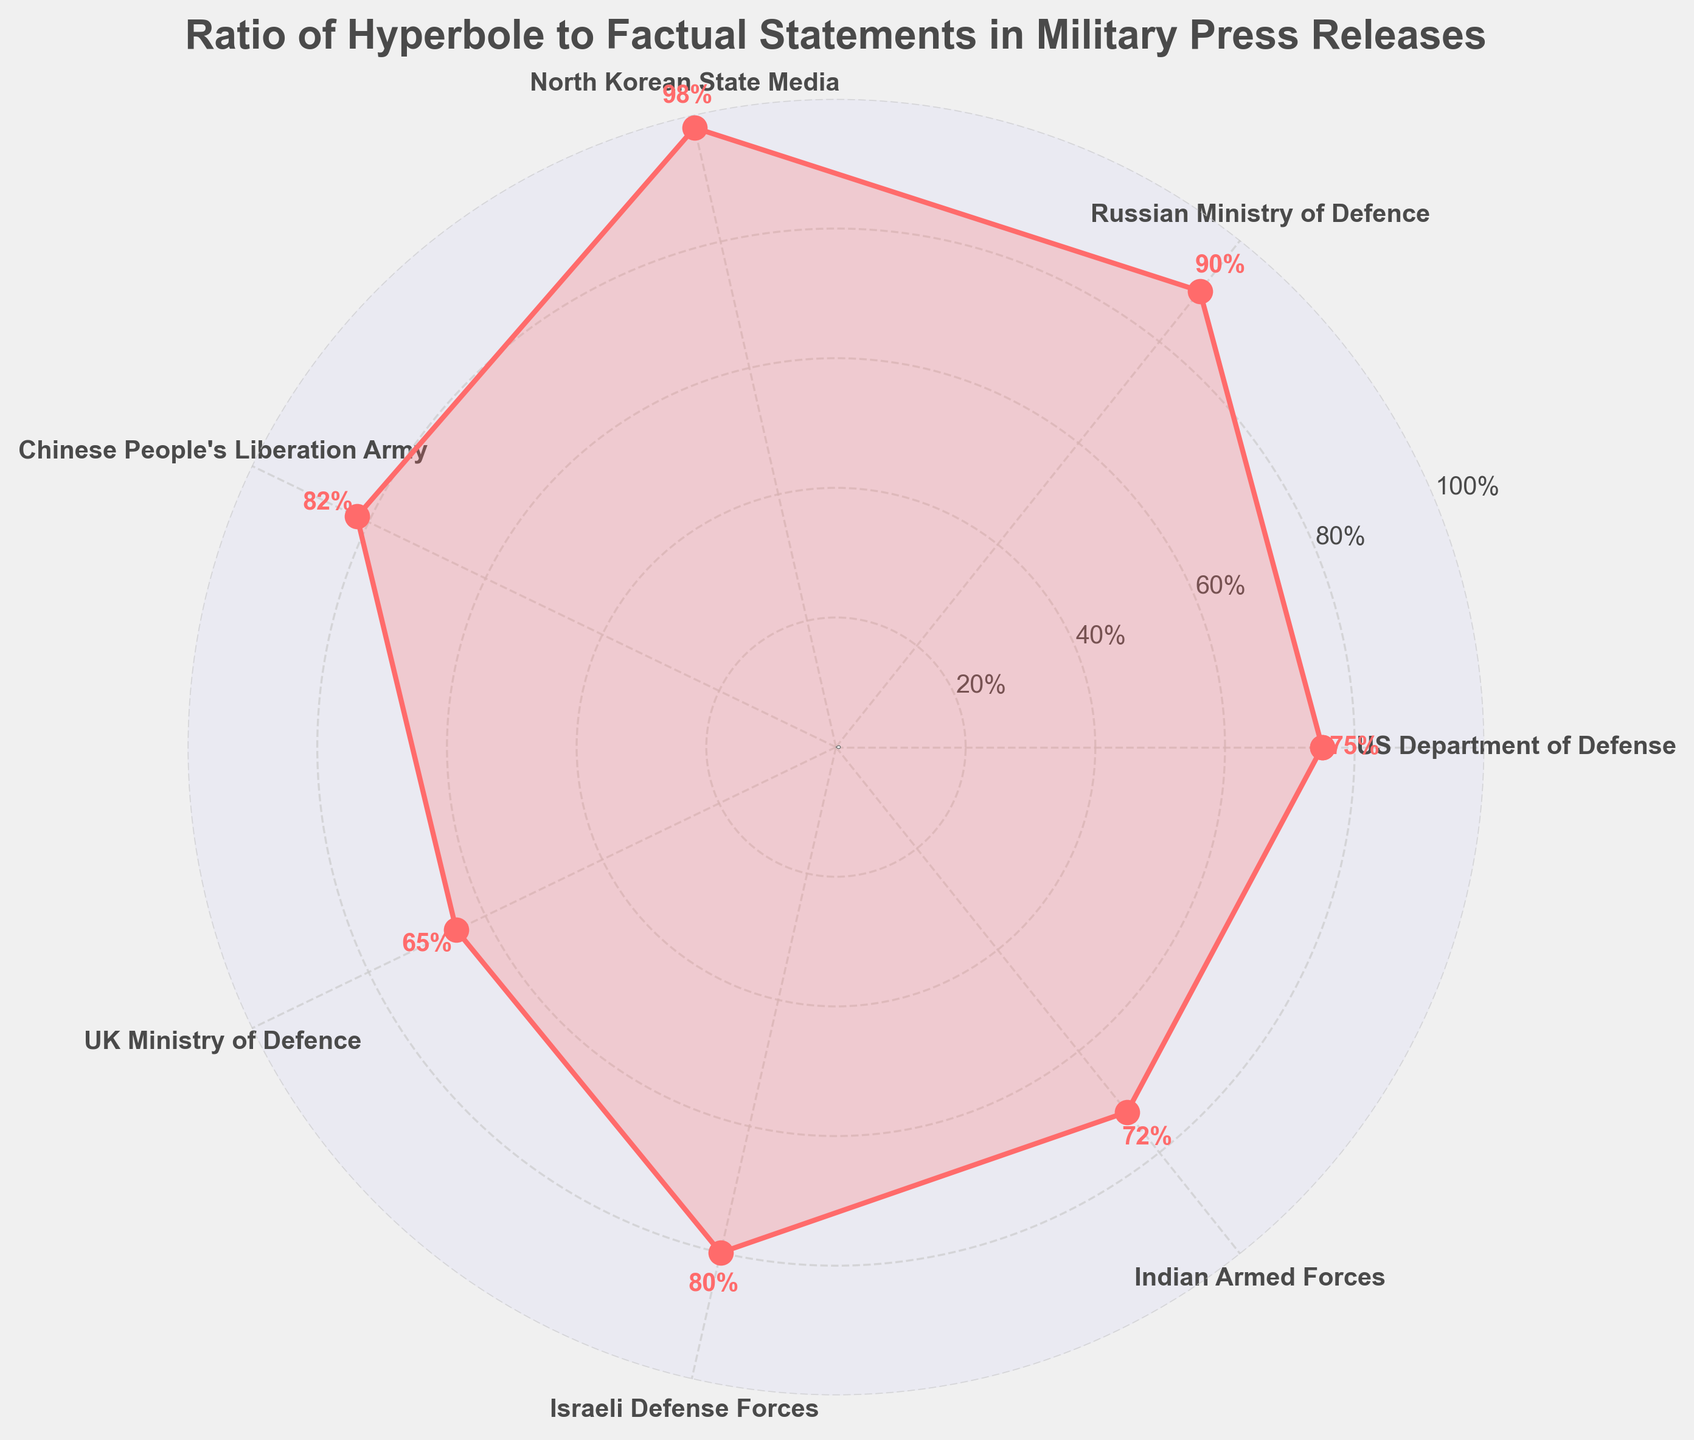How many military organizations are represented in the figure? Count the number of labeled categories in the plot. There are 7 categories represented.
Answer: 7 Which military organization has the highest ratio of hyperbole to factual statements? Identify the category with the highest value indicated on the plot. The North Korean State Media has the highest ratio at 98%.
Answer: North Korean State Media What is the range of the values represented in the figure? Subtract the smallest value from the highest value shown in the plot. The range is 98 (North Korean State Media) - 65 (UK Ministry of Defence) = 33.
Answer: 33 Which organization has the smallest ratio of hyperbole to factual statements? Identify the category with the lowest value indicated on the plot. The UK Ministry of Defence has the smallest ratio at 65%.
Answer: UK Ministry of Defence What is the median value of the ratios? Arrange the values in ascending order and find the middle value. Ordered values: 65, 72, 75, 80, 82, 90, 98. The median value, which is the fourth value in this ordered list, is 80.
Answer: 80 What is the average (mean) ratio of hyperbole to factual statements in the figure? Sum all the values and divide by the number of categories. (75 + 90 + 98 + 82 + 65 + 80 + 72) / 7 = 562 / 7 ≈ 80.29
Answer: 80.29 Which two organizations have the most similar ratios? Calculate the differences between each pair of values and find the smallest difference. The smallest difference is between the Israeli Defense Forces (80) and the Indian Armed Forces (72), a difference of 8.
Answer: Israeli Defense Forces & Indian Armed Forces How many organizations have a ratio equal to or above 80%? Count the categories that have values 80% or higher. The US Department of Defense (75), Russian Ministry of Defence (90), North Korean State Media (98), Chinese People's Liberation Army (82), UK Ministry of Defence (65), Israeli Defense Forces (80), Indian Armed Forces (72). Only 4 categories fit this criteria: Russian Ministry of Defence (90), North Korean State Media (98), Chinese People's Liberation Army (82), and Israeli Defense Forces (80).
Answer: 4 Are there more organizations with a ratio above 75% or below 75%? Count the categories with values above 75% and those with values below 75%. There are 5 organizations with ratios above 75% (Russian Ministry of Defence, North Korean State Media, Chinese People's Liberation Army, Israeli Defense Forces, Indian Armed Forces), and 2 organizations below 75% (US Department of Defense, UK Ministry of Defence).
Answer: Above 75% What's the title of the gauge chart? Look at the text at the top of the chart, typically the title of the chart. The title is "Ratio of Hyperbole to Factual Statements in Military Press Releases."
Answer: Ratio of Hyperbole to Factual Statements in Military Press Releases 